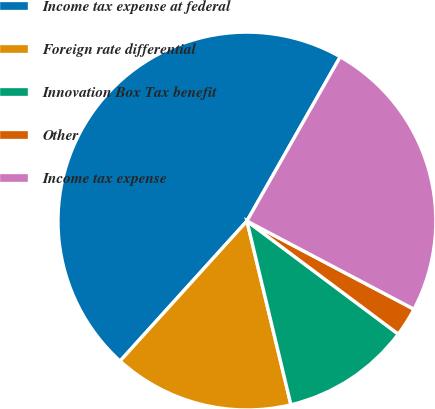Convert chart to OTSL. <chart><loc_0><loc_0><loc_500><loc_500><pie_chart><fcel>Income tax expense at federal<fcel>Foreign rate differential<fcel>Innovation Box Tax benefit<fcel>Other<fcel>Income tax expense<nl><fcel>46.51%<fcel>15.46%<fcel>11.05%<fcel>2.48%<fcel>24.51%<nl></chart> 